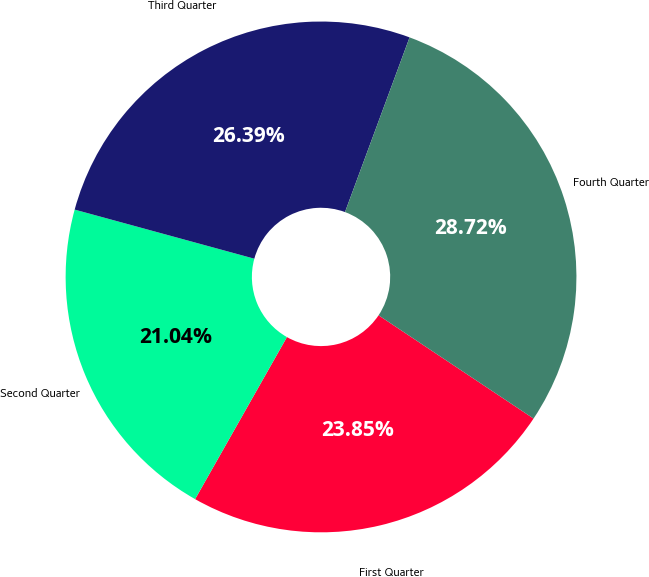Convert chart to OTSL. <chart><loc_0><loc_0><loc_500><loc_500><pie_chart><fcel>First Quarter<fcel>Second Quarter<fcel>Third Quarter<fcel>Fourth Quarter<nl><fcel>23.85%<fcel>21.04%<fcel>26.39%<fcel>28.72%<nl></chart> 